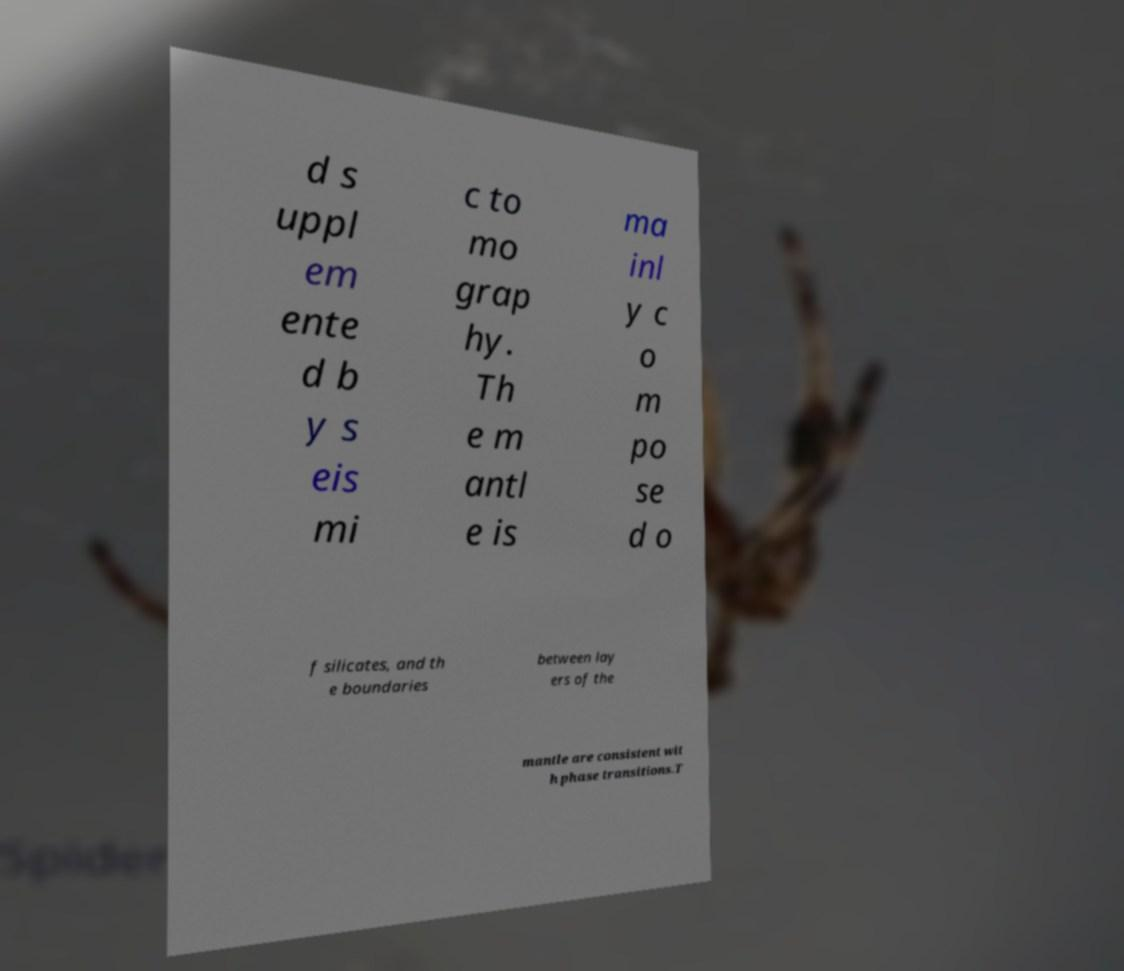There's text embedded in this image that I need extracted. Can you transcribe it verbatim? d s uppl em ente d b y s eis mi c to mo grap hy. Th e m antl e is ma inl y c o m po se d o f silicates, and th e boundaries between lay ers of the mantle are consistent wit h phase transitions.T 